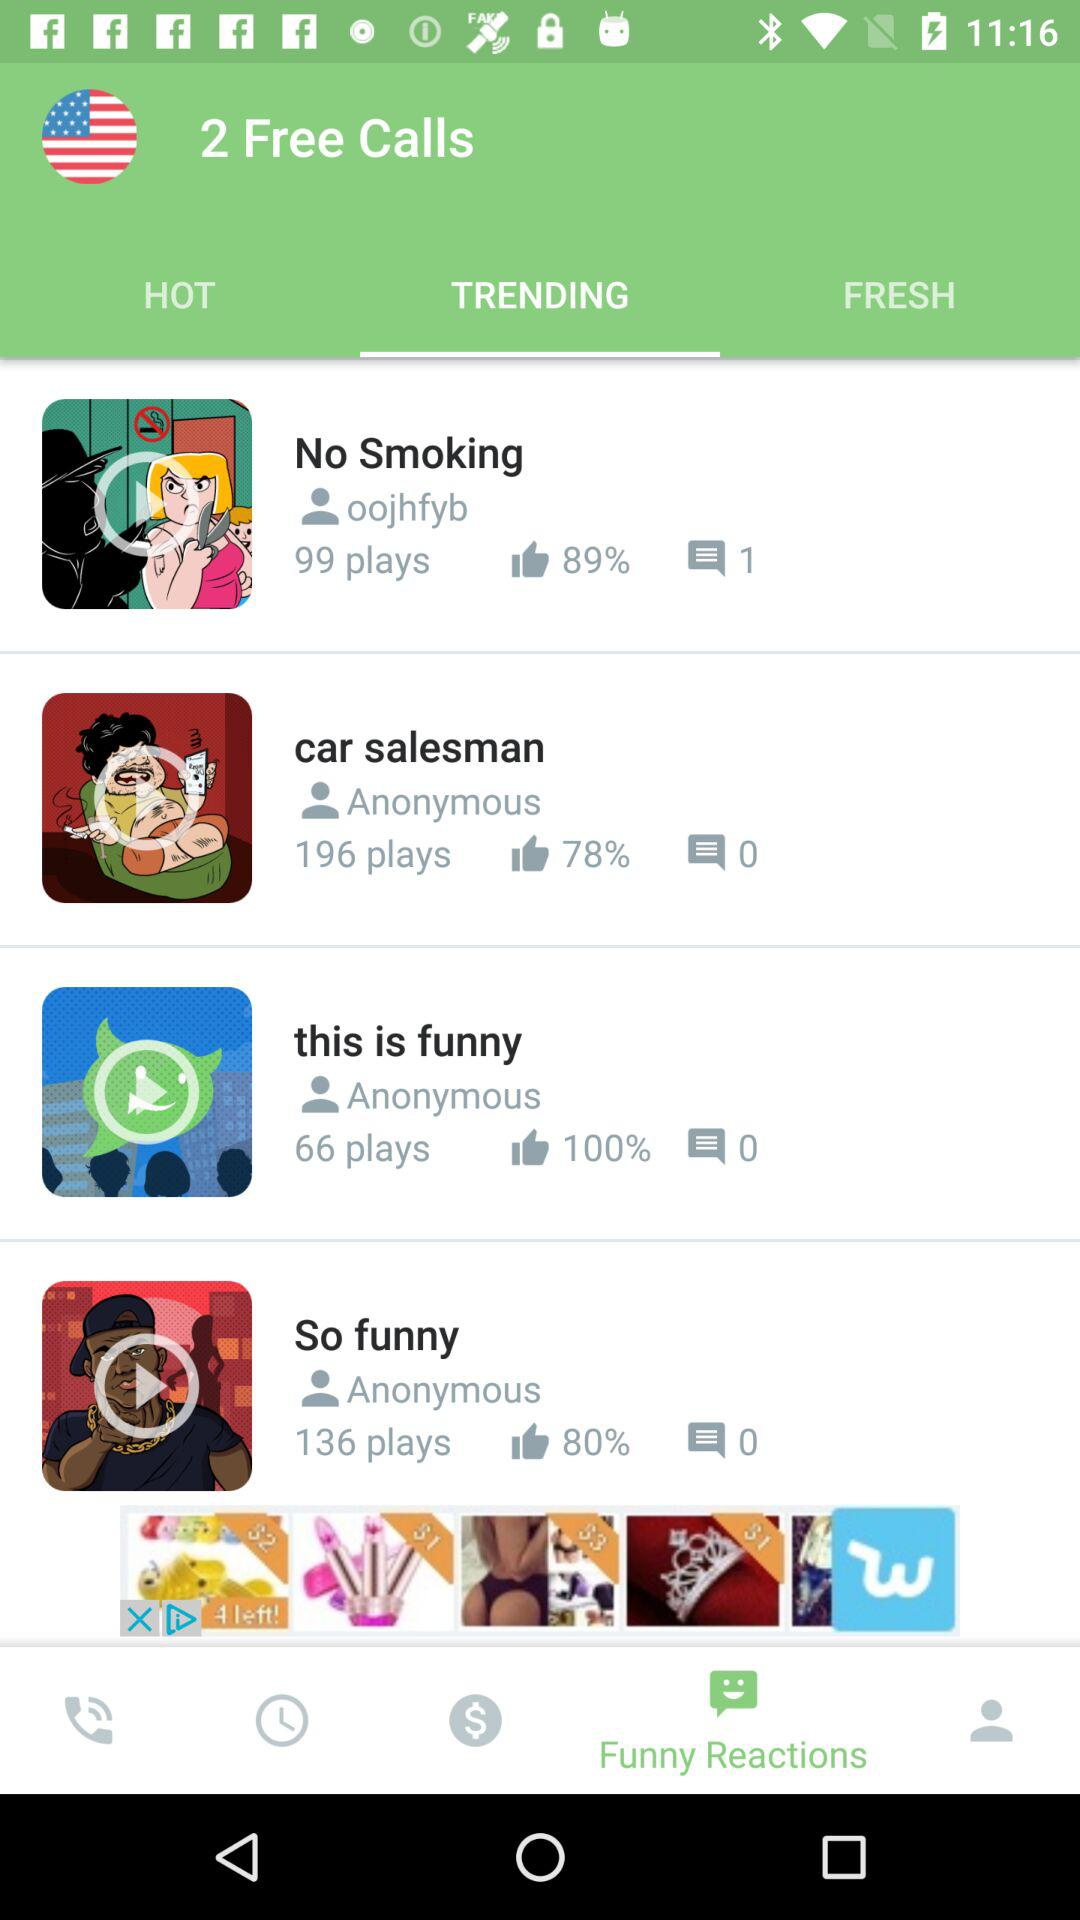Which tab am I on? You are on the "TRENDING" tab. 